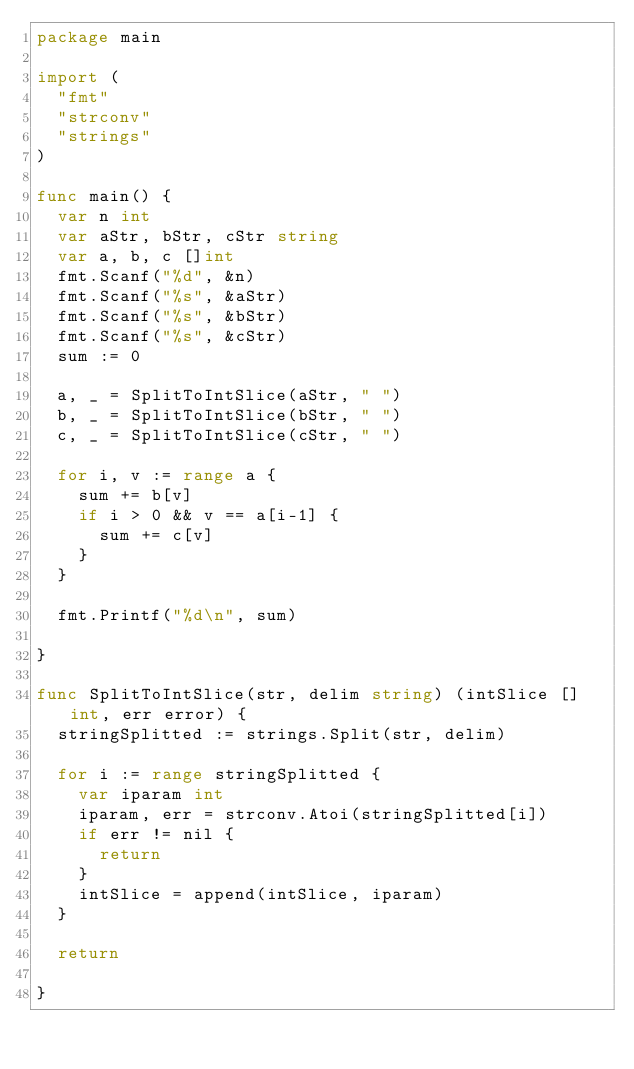Convert code to text. <code><loc_0><loc_0><loc_500><loc_500><_Go_>package main

import (
	"fmt"
	"strconv"
	"strings"
)

func main() {
	var n int
	var aStr, bStr, cStr string
	var a, b, c []int
	fmt.Scanf("%d", &n)
	fmt.Scanf("%s", &aStr)
	fmt.Scanf("%s", &bStr)
	fmt.Scanf("%s", &cStr)
	sum := 0

	a, _ = SplitToIntSlice(aStr, " ")
	b, _ = SplitToIntSlice(bStr, " ")
	c, _ = SplitToIntSlice(cStr, " ")

	for i, v := range a {
		sum += b[v]
		if i > 0 && v == a[i-1] {
			sum += c[v]
		}
	}

	fmt.Printf("%d\n", sum)

}

func SplitToIntSlice(str, delim string) (intSlice []int, err error) {
	stringSplitted := strings.Split(str, delim)

	for i := range stringSplitted {
		var iparam int
		iparam, err = strconv.Atoi(stringSplitted[i])
		if err != nil {
			return
		}
		intSlice = append(intSlice, iparam)
	}

	return

}
</code> 